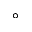Convert formula to latex. <formula><loc_0><loc_0><loc_500><loc_500>^ { \circ }</formula> 